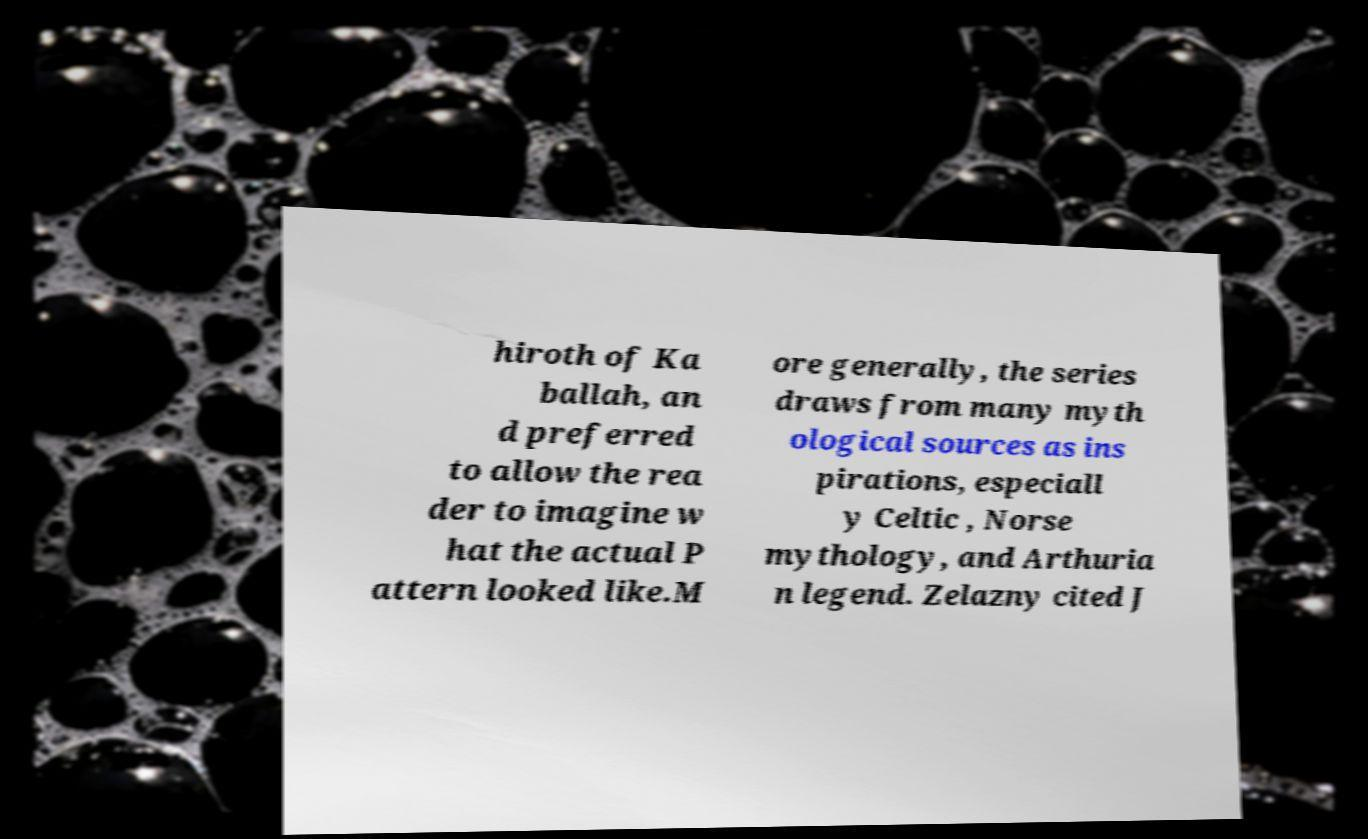There's text embedded in this image that I need extracted. Can you transcribe it verbatim? hiroth of Ka ballah, an d preferred to allow the rea der to imagine w hat the actual P attern looked like.M ore generally, the series draws from many myth ological sources as ins pirations, especiall y Celtic , Norse mythology, and Arthuria n legend. Zelazny cited J 